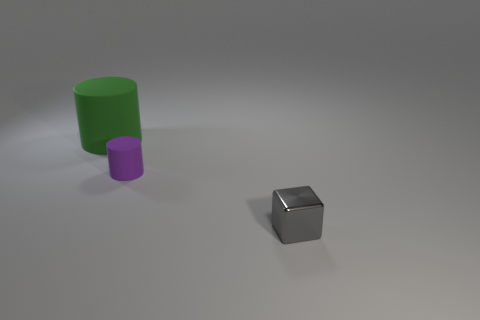There is a small thing that is the same material as the big green thing; what shape is it?
Offer a terse response. Cylinder. How many other objects are there of the same shape as the metal object?
Offer a very short reply. 0. How many objects are either small objects that are in front of the tiny matte object or small things behind the small cube?
Your answer should be compact. 2. There is a thing that is to the left of the shiny cube and in front of the green cylinder; what size is it?
Provide a short and direct response. Small. Does the matte thing that is on the right side of the big green cylinder have the same shape as the green object?
Offer a terse response. Yes. There is a matte thing in front of the cylinder that is on the left side of the matte cylinder that is right of the big cylinder; how big is it?
Your answer should be very brief. Small. How many objects are tiny gray blocks or purple cubes?
Your response must be concise. 1. There is a thing that is both in front of the green matte object and to the left of the small shiny block; what shape is it?
Your answer should be very brief. Cylinder. There is a green object; does it have the same shape as the tiny thing behind the metal thing?
Provide a short and direct response. Yes. There is a tiny shiny block; are there any gray things behind it?
Provide a short and direct response. No. 